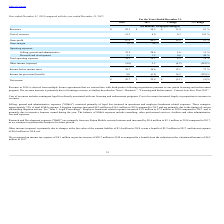From Finjan Holding's financial document, What are the respective increase in R&D expenses between 2017 and 2018, as well as the R&D expenses in 2018? The document shows two values: $0.6 million and $2.1 million. From the document: "r Finjan Mobile security business and increased by $0.6 million to $2.1 million in 2018 compared to 2017, as we continue to position this business for..." Also, What are the respective fair value of the warrant liability and interest expense in 2018? The document shows two values: $3.4 million and $0.6 million. From the document: "r Finjan Mobile security business and increased by $0.6 million to $2.1 million in 2018 compared to 2017, as we continue to position this business for..." Also, What are the respective income tax expense and pre-tax income in 2018? The document shows two values: $8.1 million and $28.7 million. From the document: "e tax expense of $8.1 million on pre-tax income of $28.7 million in 2018 as compared to a benefit from the reduction in the valuation allowance of $6...." Also, can you calculate: What is the value of pre-tax income as a percentage of revenues in 2018? Based on the calculation: 28.7/82.3, the result is 34.87 (percentage). This is based on the information: "Revenues $ 82.3 $ 50.5 $ 31.8 63 % Income before income taxes 28.7 16.6 12.1 73 %..." The key data points involved are: 28.7, 82.3. Also, can you calculate: What is the value of the warrant liability fair value as a percentage of the cost of revenues in 2018? Based on the calculation: 3.4/15.3, the result is 22.22 (percentage). This is based on the information: "Cost of revenues 15.3 6.0 9.3 155 % es in the fair value of the warrant liability of $3.4 million in 2018 versus a benefit of $2.2 million in 2017, and interest expense of $0.6 million in 2..." The key data points involved are: 15.3, 3.4. Also, can you calculate: What is the value of R&D expenses as a percentage of the cost of revenues in 2018? Based on the calculation: 2.1/15.3 , the result is 13.73 (percentage). This is based on the information: "Cost of revenues 15.3 6.0 9.3 155 % Research and development 2.1 1.5 0.6 40 %..." The key data points involved are: 15.3, 2.1. 